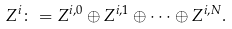<formula> <loc_0><loc_0><loc_500><loc_500>Z ^ { i } \colon = Z ^ { i , 0 } \oplus Z ^ { i , 1 } \oplus \dots \oplus Z ^ { i , N } .</formula> 